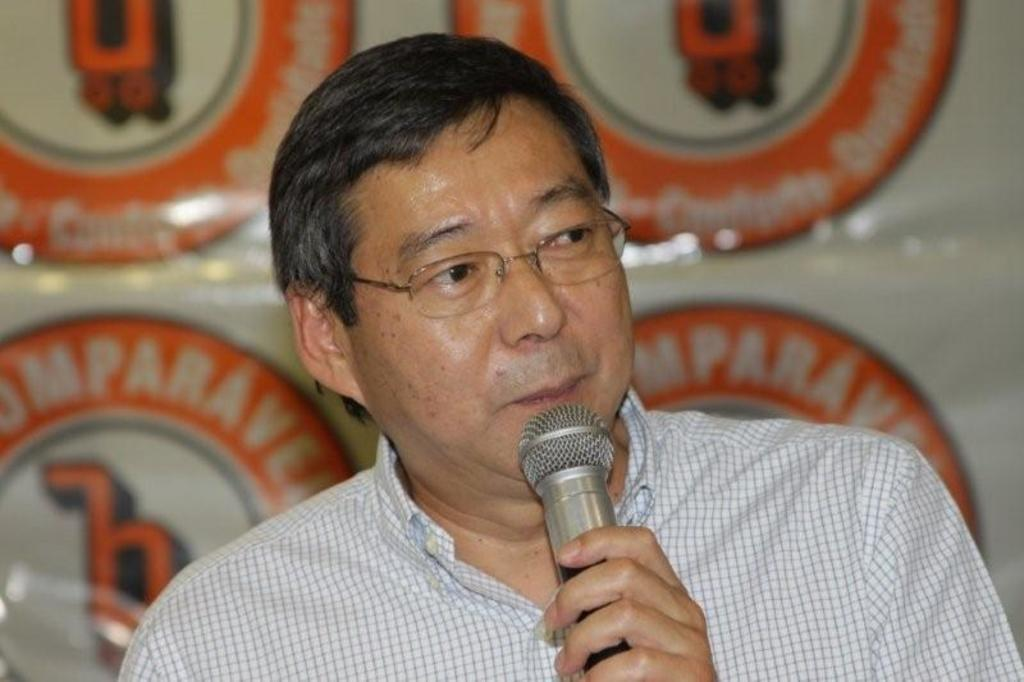What is the man in the image doing? The man is holding a microphone and talking. What is the man wearing in the image? The man is wearing a shirt and glasses. What can be seen in the background of the image? There is a banner visible in the background. How many circles can be seen in the picture? There is no circle present in the image. What type of picture is the man holding in the image? The man is not holding a picture in the image; he is holding a microphone. 